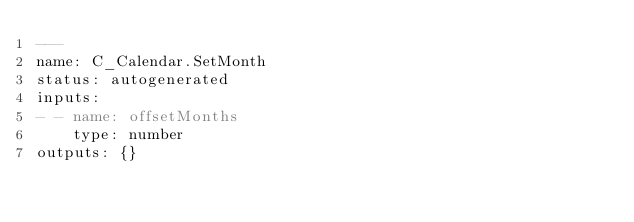Convert code to text. <code><loc_0><loc_0><loc_500><loc_500><_YAML_>---
name: C_Calendar.SetMonth
status: autogenerated
inputs:
- - name: offsetMonths
    type: number
outputs: {}
</code> 